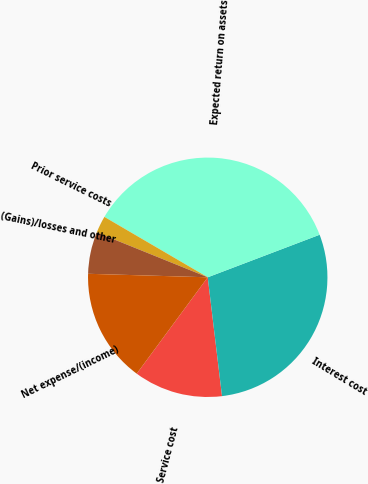Convert chart. <chart><loc_0><loc_0><loc_500><loc_500><pie_chart><fcel>Service cost<fcel>Interest cost<fcel>Expected return on assets<fcel>Prior service costs<fcel>(Gains)/losses and other<fcel>Net expense/(income)<nl><fcel>12.01%<fcel>28.88%<fcel>35.8%<fcel>2.3%<fcel>5.65%<fcel>15.36%<nl></chart> 